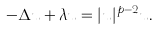Convert formula to latex. <formula><loc_0><loc_0><loc_500><loc_500>- \Delta u + \lambda u = | u | ^ { p - 2 } u .</formula> 